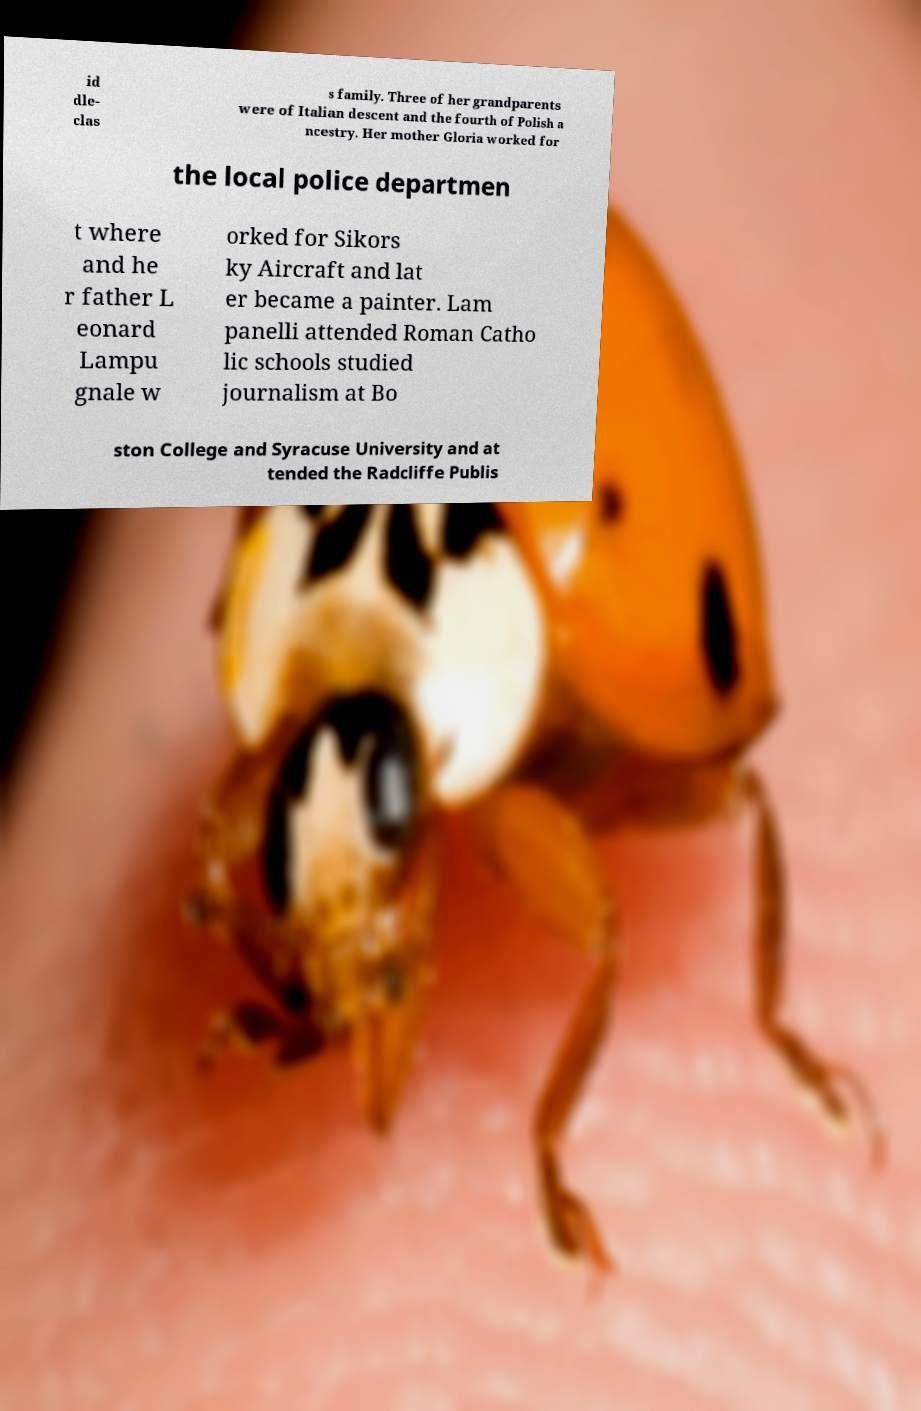Can you accurately transcribe the text from the provided image for me? id dle- clas s family. Three of her grandparents were of Italian descent and the fourth of Polish a ncestry. Her mother Gloria worked for the local police departmen t where and he r father L eonard Lampu gnale w orked for Sikors ky Aircraft and lat er became a painter. Lam panelli attended Roman Catho lic schools studied journalism at Bo ston College and Syracuse University and at tended the Radcliffe Publis 